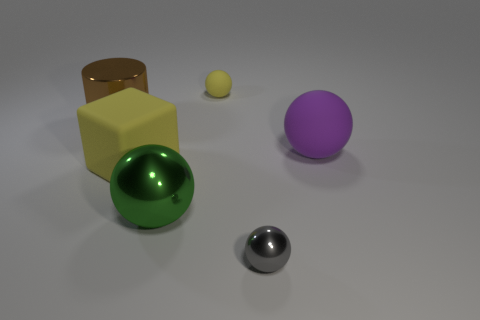Subtract all tiny yellow spheres. How many spheres are left? 3 Subtract all gray balls. How many balls are left? 3 Subtract all cyan spheres. Subtract all red cylinders. How many spheres are left? 4 Add 4 big objects. How many objects exist? 10 Subtract all cubes. How many objects are left? 5 Subtract 0 cyan balls. How many objects are left? 6 Subtract all small objects. Subtract all gray shiny balls. How many objects are left? 3 Add 1 gray shiny spheres. How many gray shiny spheres are left? 2 Add 3 matte blocks. How many matte blocks exist? 4 